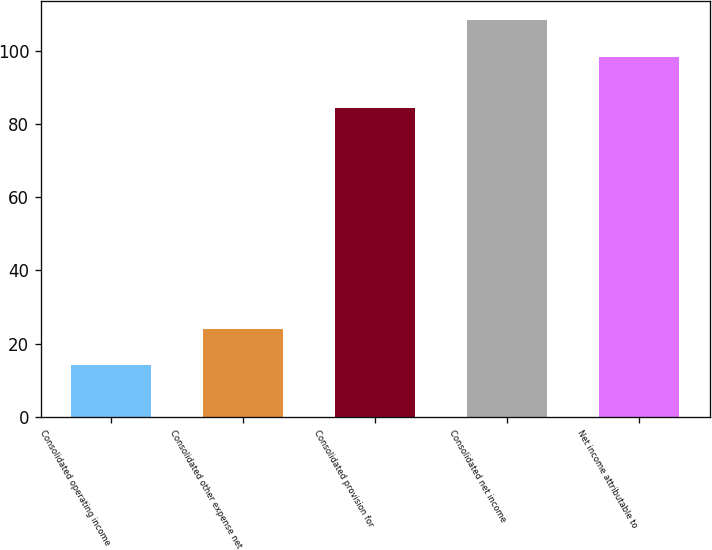Convert chart. <chart><loc_0><loc_0><loc_500><loc_500><bar_chart><fcel>Consolidated operating income<fcel>Consolidated other expense net<fcel>Consolidated provision for<fcel>Consolidated net income<fcel>Net income attributable to<nl><fcel>14.25<fcel>24.1<fcel>84.5<fcel>108.35<fcel>98.5<nl></chart> 